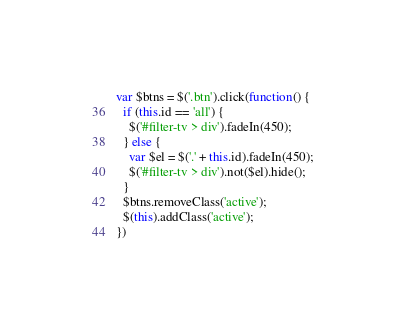<code> <loc_0><loc_0><loc_500><loc_500><_JavaScript_>var $btns = $('.btn').click(function() {
  if (this.id == 'all') {
    $('#filter-tv > div').fadeIn(450);
  } else {
    var $el = $('.' + this.id).fadeIn(450);
    $('#filter-tv > div').not($el).hide();
  }
  $btns.removeClass('active');
  $(this).addClass('active');
})</code> 